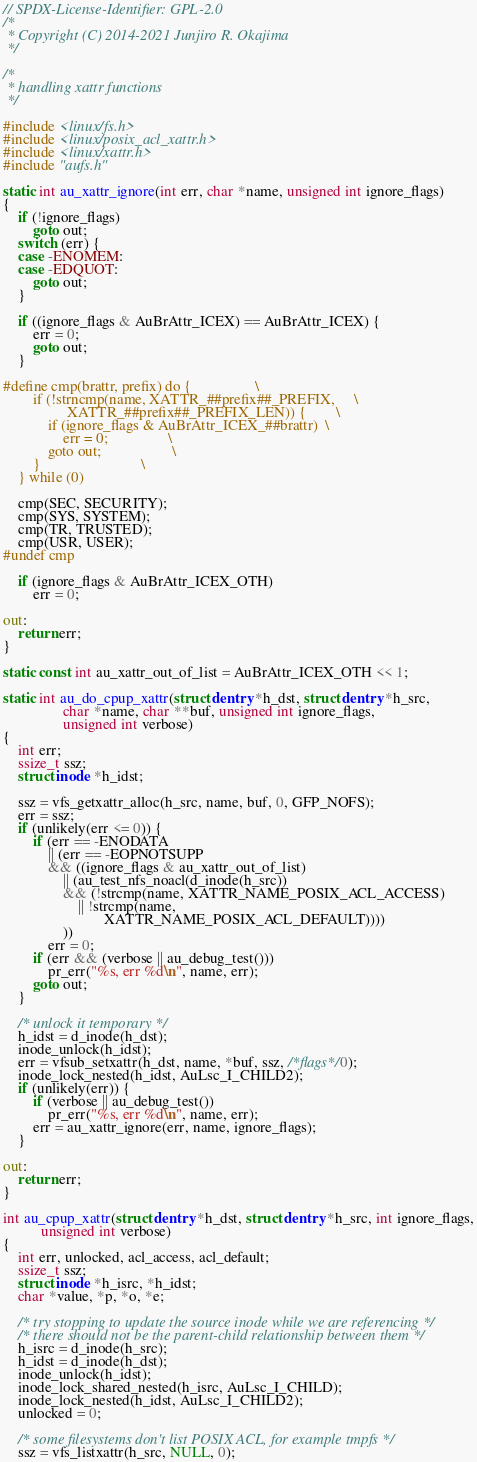<code> <loc_0><loc_0><loc_500><loc_500><_C_>// SPDX-License-Identifier: GPL-2.0
/*
 * Copyright (C) 2014-2021 Junjiro R. Okajima
 */

/*
 * handling xattr functions
 */

#include <linux/fs.h>
#include <linux/posix_acl_xattr.h>
#include <linux/xattr.h>
#include "aufs.h"

static int au_xattr_ignore(int err, char *name, unsigned int ignore_flags)
{
	if (!ignore_flags)
		goto out;
	switch (err) {
	case -ENOMEM:
	case -EDQUOT:
		goto out;
	}

	if ((ignore_flags & AuBrAttr_ICEX) == AuBrAttr_ICEX) {
		err = 0;
		goto out;
	}

#define cmp(brattr, prefix) do {					\
		if (!strncmp(name, XATTR_##prefix##_PREFIX,		\
			     XATTR_##prefix##_PREFIX_LEN)) {		\
			if (ignore_flags & AuBrAttr_ICEX_##brattr)	\
				err = 0;				\
			goto out;					\
		}							\
	} while (0)

	cmp(SEC, SECURITY);
	cmp(SYS, SYSTEM);
	cmp(TR, TRUSTED);
	cmp(USR, USER);
#undef cmp

	if (ignore_flags & AuBrAttr_ICEX_OTH)
		err = 0;

out:
	return err;
}

static const int au_xattr_out_of_list = AuBrAttr_ICEX_OTH << 1;

static int au_do_cpup_xattr(struct dentry *h_dst, struct dentry *h_src,
			    char *name, char **buf, unsigned int ignore_flags,
			    unsigned int verbose)
{
	int err;
	ssize_t ssz;
	struct inode *h_idst;

	ssz = vfs_getxattr_alloc(h_src, name, buf, 0, GFP_NOFS);
	err = ssz;
	if (unlikely(err <= 0)) {
		if (err == -ENODATA
		    || (err == -EOPNOTSUPP
			&& ((ignore_flags & au_xattr_out_of_list)
			    || (au_test_nfs_noacl(d_inode(h_src))
				&& (!strcmp(name, XATTR_NAME_POSIX_ACL_ACCESS)
				    || !strcmp(name,
					       XATTR_NAME_POSIX_ACL_DEFAULT))))
			    ))
			err = 0;
		if (err && (verbose || au_debug_test()))
			pr_err("%s, err %d\n", name, err);
		goto out;
	}

	/* unlock it temporary */
	h_idst = d_inode(h_dst);
	inode_unlock(h_idst);
	err = vfsub_setxattr(h_dst, name, *buf, ssz, /*flags*/0);
	inode_lock_nested(h_idst, AuLsc_I_CHILD2);
	if (unlikely(err)) {
		if (verbose || au_debug_test())
			pr_err("%s, err %d\n", name, err);
		err = au_xattr_ignore(err, name, ignore_flags);
	}

out:
	return err;
}

int au_cpup_xattr(struct dentry *h_dst, struct dentry *h_src, int ignore_flags,
		  unsigned int verbose)
{
	int err, unlocked, acl_access, acl_default;
	ssize_t ssz;
	struct inode *h_isrc, *h_idst;
	char *value, *p, *o, *e;

	/* try stopping to update the source inode while we are referencing */
	/* there should not be the parent-child relationship between them */
	h_isrc = d_inode(h_src);
	h_idst = d_inode(h_dst);
	inode_unlock(h_idst);
	inode_lock_shared_nested(h_isrc, AuLsc_I_CHILD);
	inode_lock_nested(h_idst, AuLsc_I_CHILD2);
	unlocked = 0;

	/* some filesystems don't list POSIX ACL, for example tmpfs */
	ssz = vfs_listxattr(h_src, NULL, 0);</code> 